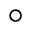Convert formula to latex. <formula><loc_0><loc_0><loc_500><loc_500>\circ</formula> 